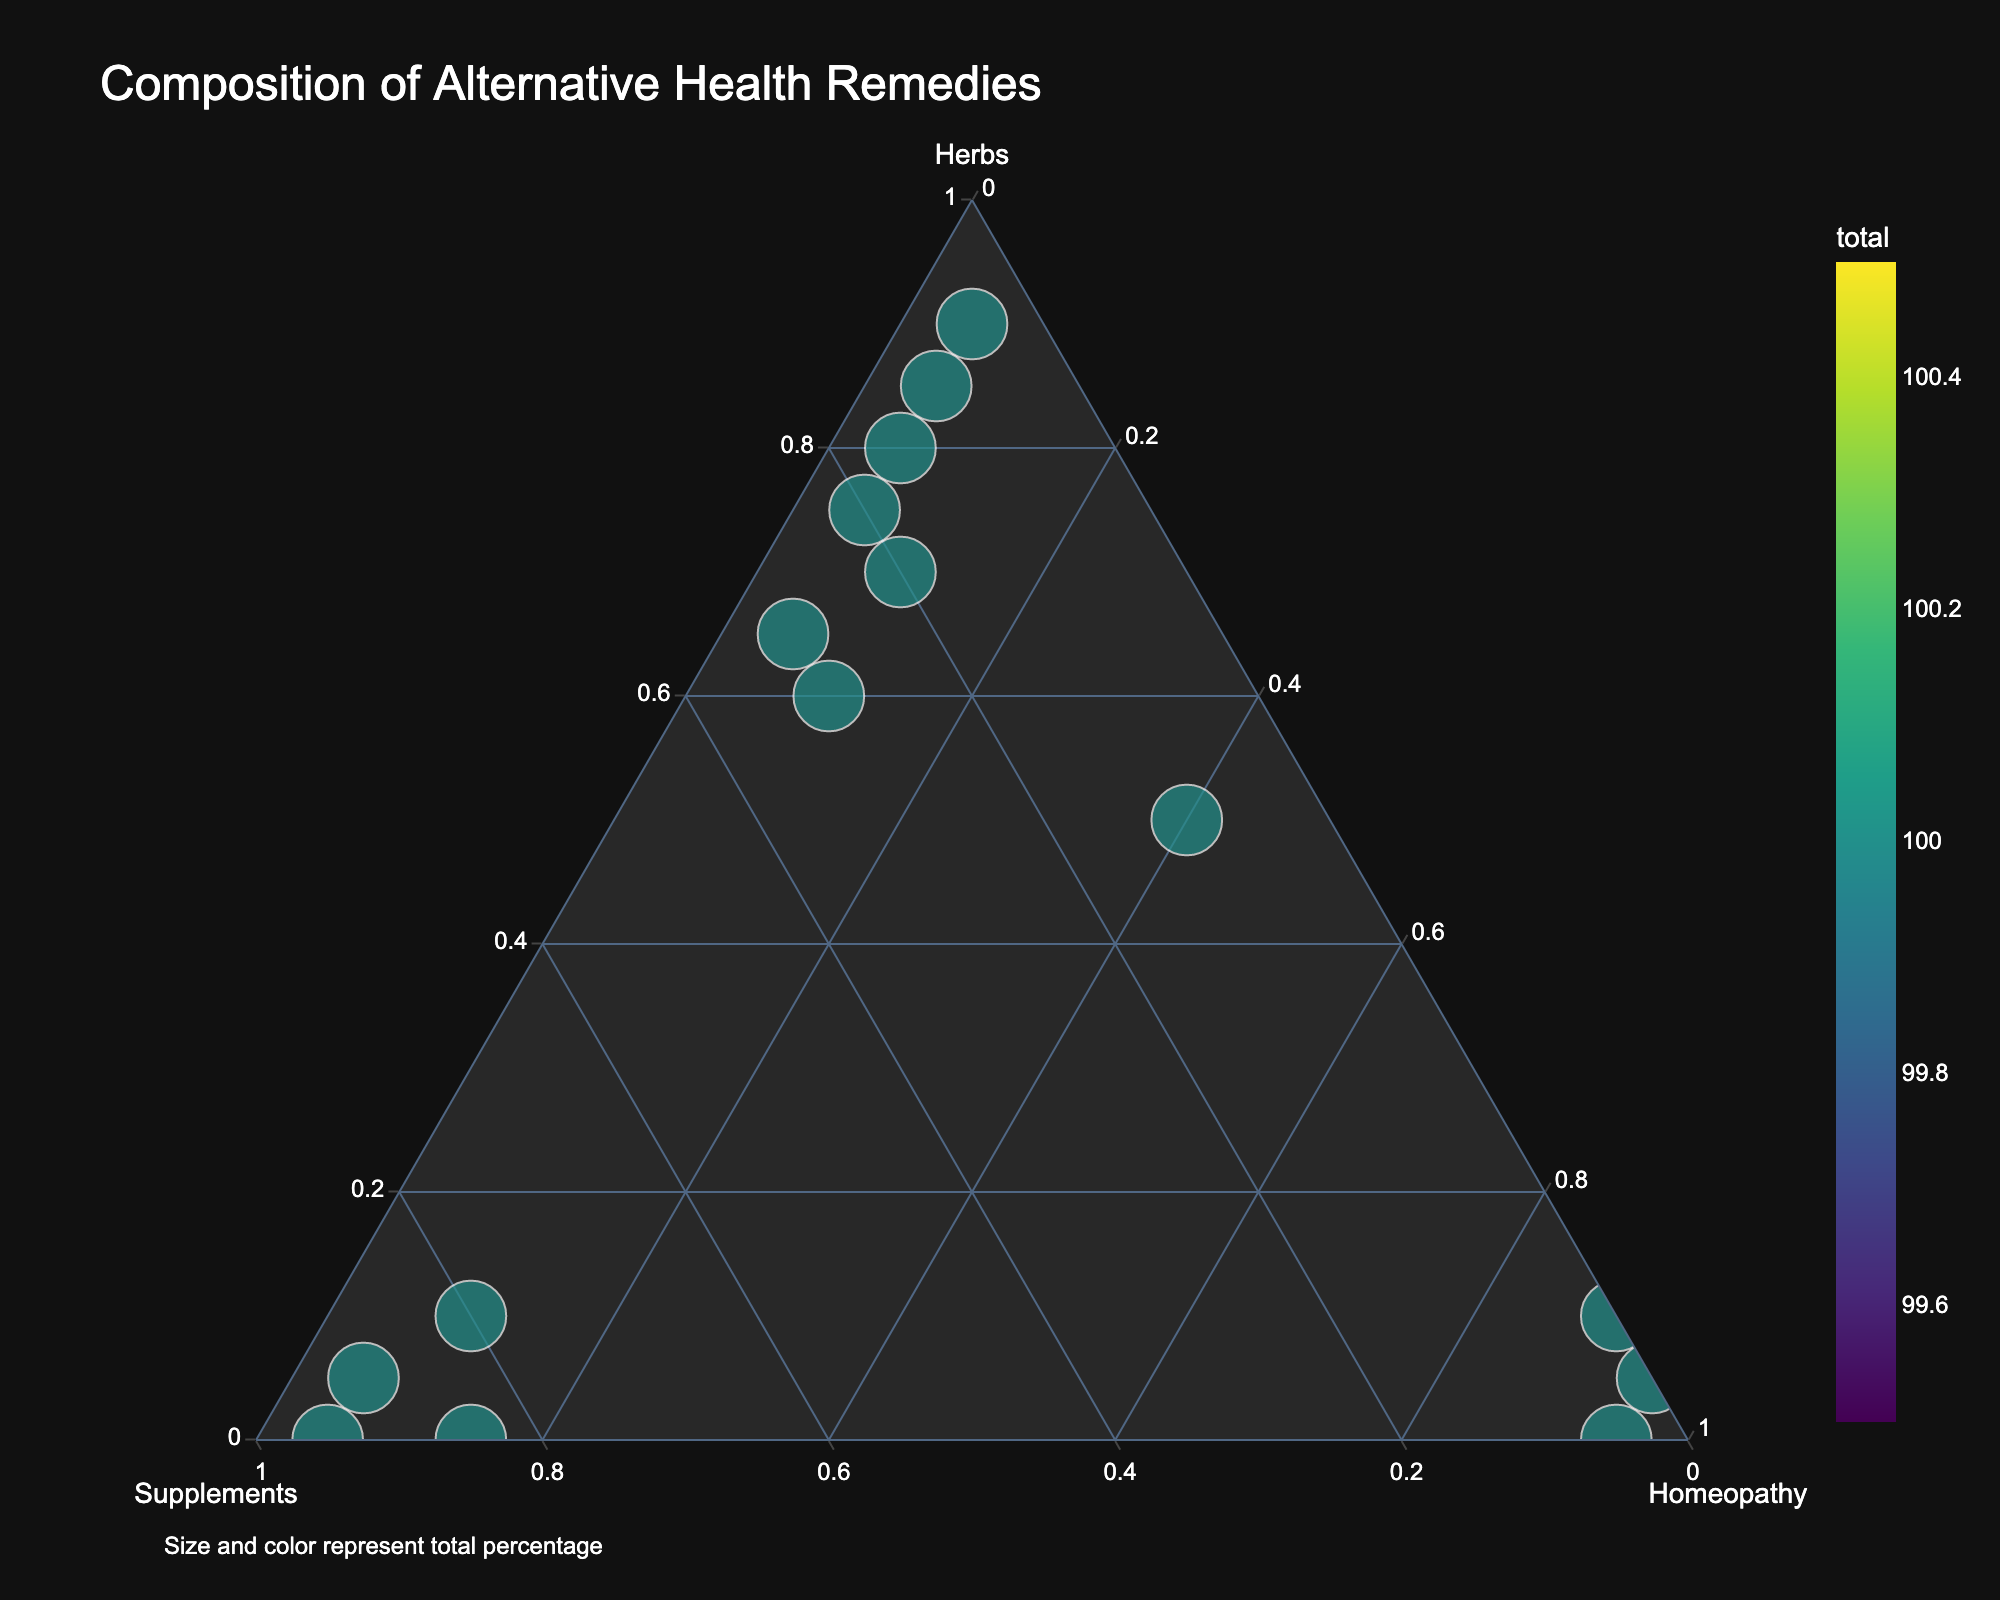What is the title of the plot? The title is typically displayed prominently at the top of the plot, and it summarizes the content or purpose of the visual representation. In this case, the title should be found at the top of the ternary plot.
Answer: Composition of Alternative Health Remedies What are the three axes labeled as? The axes in a ternary plot are labeled to represent the three components or variables being measured. By looking at the points where the axes converge, you can identify the labels.
Answer: Herbs, Supplements, Homeopathy Which remedy is composed entirely of Homeopathy? The point that lies directly on the Homeopathy axis and has coordinates (0, 0, 1) represents a remedy that is composed entirely of Homeopathy.
Answer: Oscillococcinum Which remedy has the highest total percentage? The size of the points on the plot indicates the total percentage of components in each remedy, with larger points representing higher totals. Identify the largest point on the plot to answer this question.
Answer: Elderberry Syrup How many remedies have a combination of herbs greater than 50%? By looking at the points that are situated closer to the Herbs axis, you can count how many fall into the spectrum where herbs make up more than half of the composition.
Answer: 8 Which remedy has the highest percentage of Supplements? Identify the point that lies closest to the Supplements axis and is marked with the appropriate remedy name. The position of the point will reflect the highest Supplement percentage.
Answer: Vitamin C Complex How do the compositions of Echinacea Blend and Chamomile Tea compare regarding Homeopathy? Determine the coordinates of both Echinacea Blend and Chamomile Tea, specifically their positions with respect to the Homeopathy axis. Compare these coordinates to evaluate their Homeopathy percentages.
Answer: Echinacea Blend: 10%, Chamomile Tea: 5% Which remedies have similar compositions and are located close to each other in the plot? The closeness of points on a ternary plot indicates similarity in composition. Look for pairs or clusters of remedies that are plotted near each other.
Answer: Echinacea Blend and Turmeric Tincture What's the average percentage of Herbs in the remedies with the lowest percentage of Homeopathy? First, identify the remedies with the lowest Homeopathy percentage (which is 5%), then calculate the average percentage of Herbs in these remedies by averaging their position on the Herbs axis. Steps: Identify remedies (Vitamin C Complex, Garlic Extract, Turmeric Tincture, Ginger Root, Chamomile Tea), sum their Herbs percentages (5+75+65+85+90=320), and divide by the number of remedies (320/5=64).
Answer: 64% Is there any remedy with an equal composition of Supplements and Homeopathy? Look for a point on the plot where the distances from both the Supplements and the Homeopathy axes are equal, which indicates an equal composition of these components.
Answer: No 